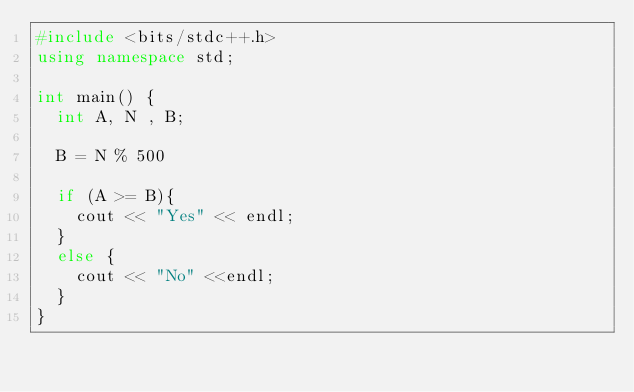<code> <loc_0><loc_0><loc_500><loc_500><_C++_>#include <bits/stdc++.h>
using namespace std;

int main() {
  int A, N , B;

  B = N % 500
    
  if (A >= B){
    cout << "Yes" << endl;
  }
  else {
    cout << "No" <<endl;
  }
}</code> 